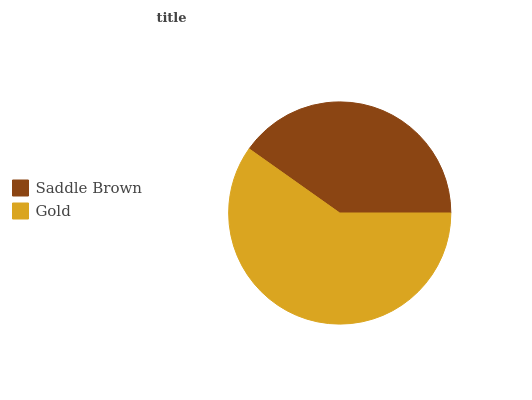Is Saddle Brown the minimum?
Answer yes or no. Yes. Is Gold the maximum?
Answer yes or no. Yes. Is Gold the minimum?
Answer yes or no. No. Is Gold greater than Saddle Brown?
Answer yes or no. Yes. Is Saddle Brown less than Gold?
Answer yes or no. Yes. Is Saddle Brown greater than Gold?
Answer yes or no. No. Is Gold less than Saddle Brown?
Answer yes or no. No. Is Gold the high median?
Answer yes or no. Yes. Is Saddle Brown the low median?
Answer yes or no. Yes. Is Saddle Brown the high median?
Answer yes or no. No. Is Gold the low median?
Answer yes or no. No. 